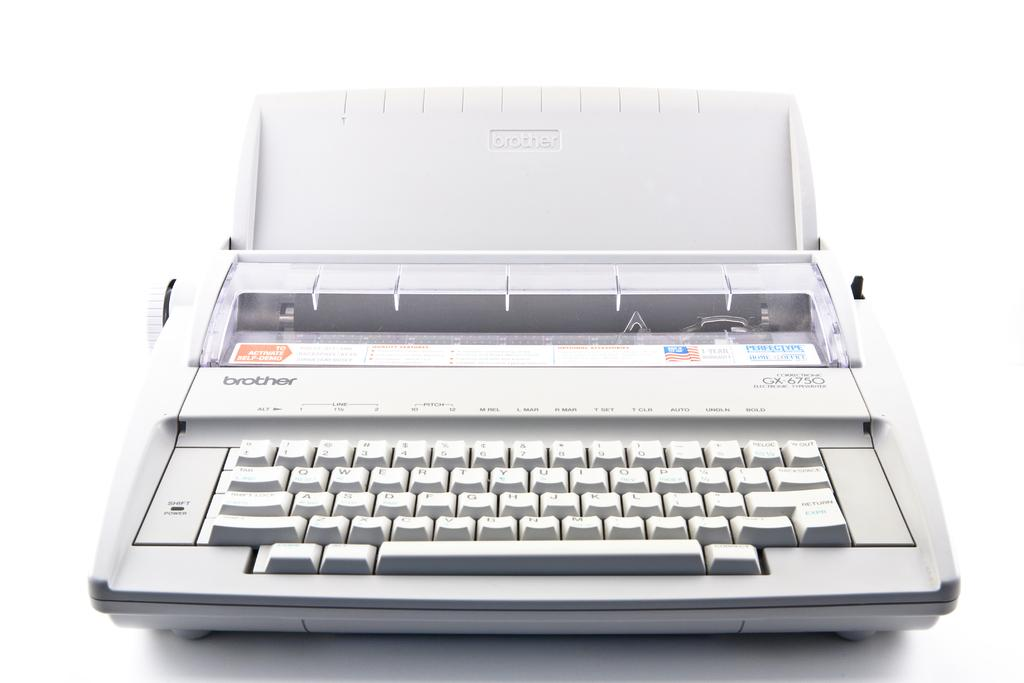<image>
Give a short and clear explanation of the subsequent image. A Brother word processor model GX-6750 has a stick with instructions to activate self demo. 